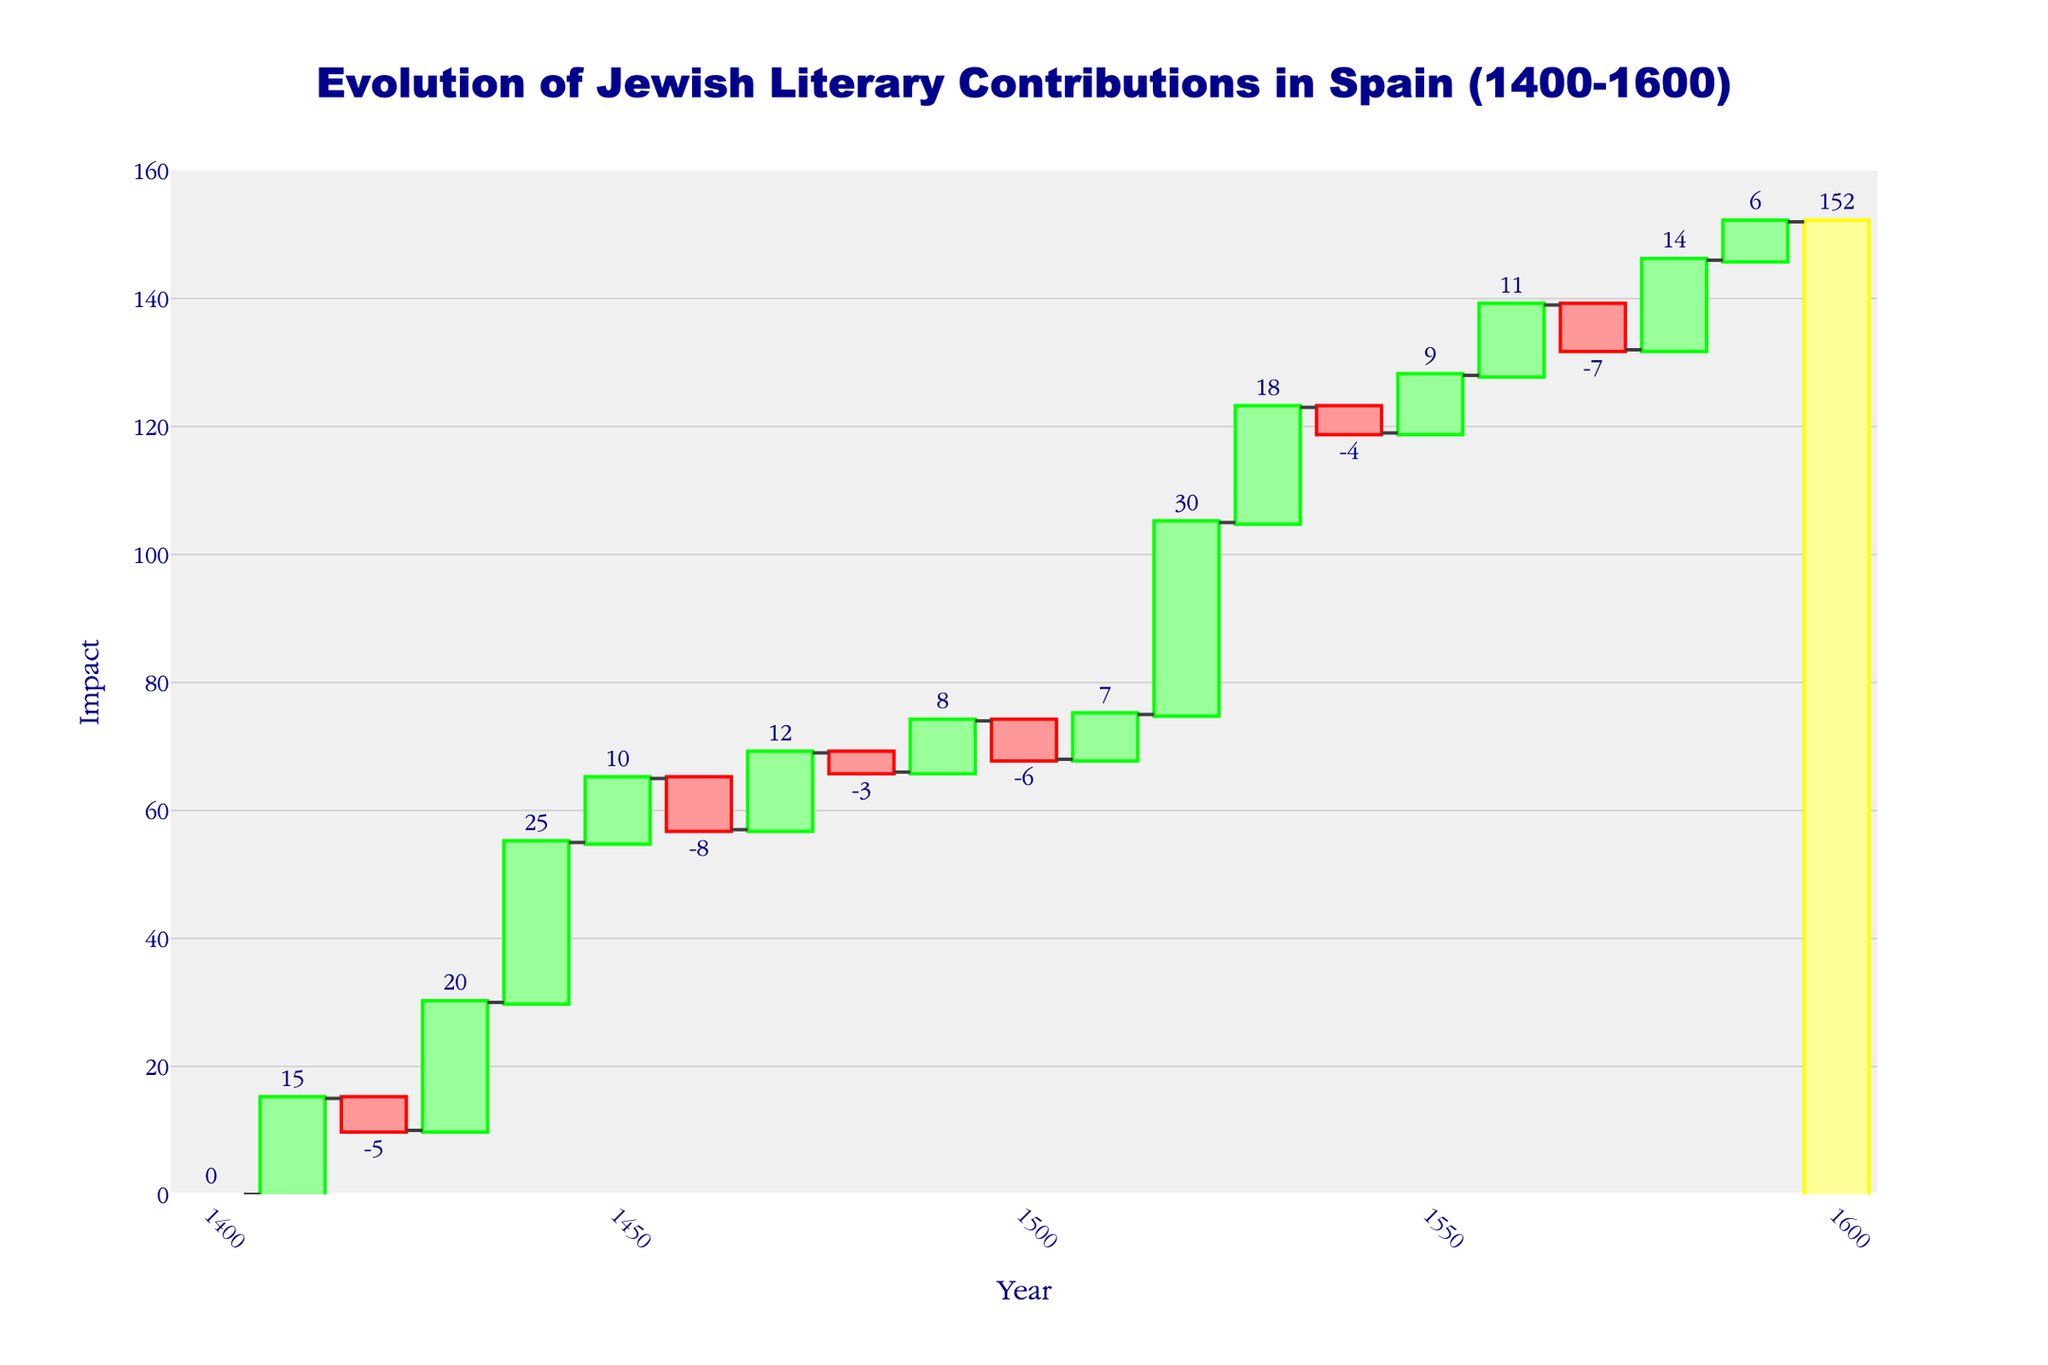What is the title of the figure? The title of the figure is displayed prominently at the top.
Answer: Evolution of Jewish Literary Contributions in Spain (1400-1600) What is the cumulative impact by 1600? The cumulative impact by 1600 is marked clearly as the last data point on the figure.
Answer: 152 Which decade had the highest positive impact in the given period? By visually identifying the highest single positive bar, we can see that Joseph Caro's 'Shulchan Aruch' in the 1520s had the highest positive impact.
Answer: 1520s What is the impact of Joseph Albo's 'Sefer ha-Ikkarim' in the 1430s? Find the data point for 1430 and see the bar height, which represents Joseph Albo's Contribution.
Answer: 20 How does the impact of Isaac Abravanel's Biblical Commentaries compare to Abraham Zacuto's Astronomical Tables? Locate the bars for 1440 and 1450, then compare their heights. Isaac Abravanel's has an impact of 25, whereas Abraham Zacuto’s is 10.
Answer: Isaac Abravanel's (25) is greater than Abraham Zacuto’s (10) Which decade saw a negative impact from Isaac Aboab II's 'Menorat ha-Maor'? Check for the data point of 1460 and observe its downward bar.
Answer: 1460 What is the total of all positive impacts from 1400 to 1600? Sum the heights of all positive bars: 15 (1410) + 20 (1430) + 25 (1440) + 10 (1450) + 12 (1470) + 8 (1490) + 7 (1510) + 30 (1520) + 18 (1530) + 9 (1550) + 11 (1560) + 14 (1580) + 6 (1590).
Answer: 185 What is the average impact per decade across the entire period? Calculate the average impact by summing all the impacts and dividing by the number of decades: (0 + 15 - 5 + 20 + 25 + 10 - 8 + 12 - 3 + 8 - 6 + 7 + 30 + 18 - 4 + 9 + 11 - 7 + 14 + 6) / 20
Answer: 7.6 Which decade had a positive impact from both Isaac Arama's contributions? Check the data points for Isaac Arama's contributions in 1410 and 1490, and see which decades they correspond to. Each had a positive impact of 15 and 8 respectively.
Answer: 1410s and 1490s Which decade experienced the largest negative impact? Identify the decade with the most significant downward bar, which is seen in the 1520 data point from Isaac Aboab II's 'Menorat ha-Maor' (-8).
Answer: 1460s 